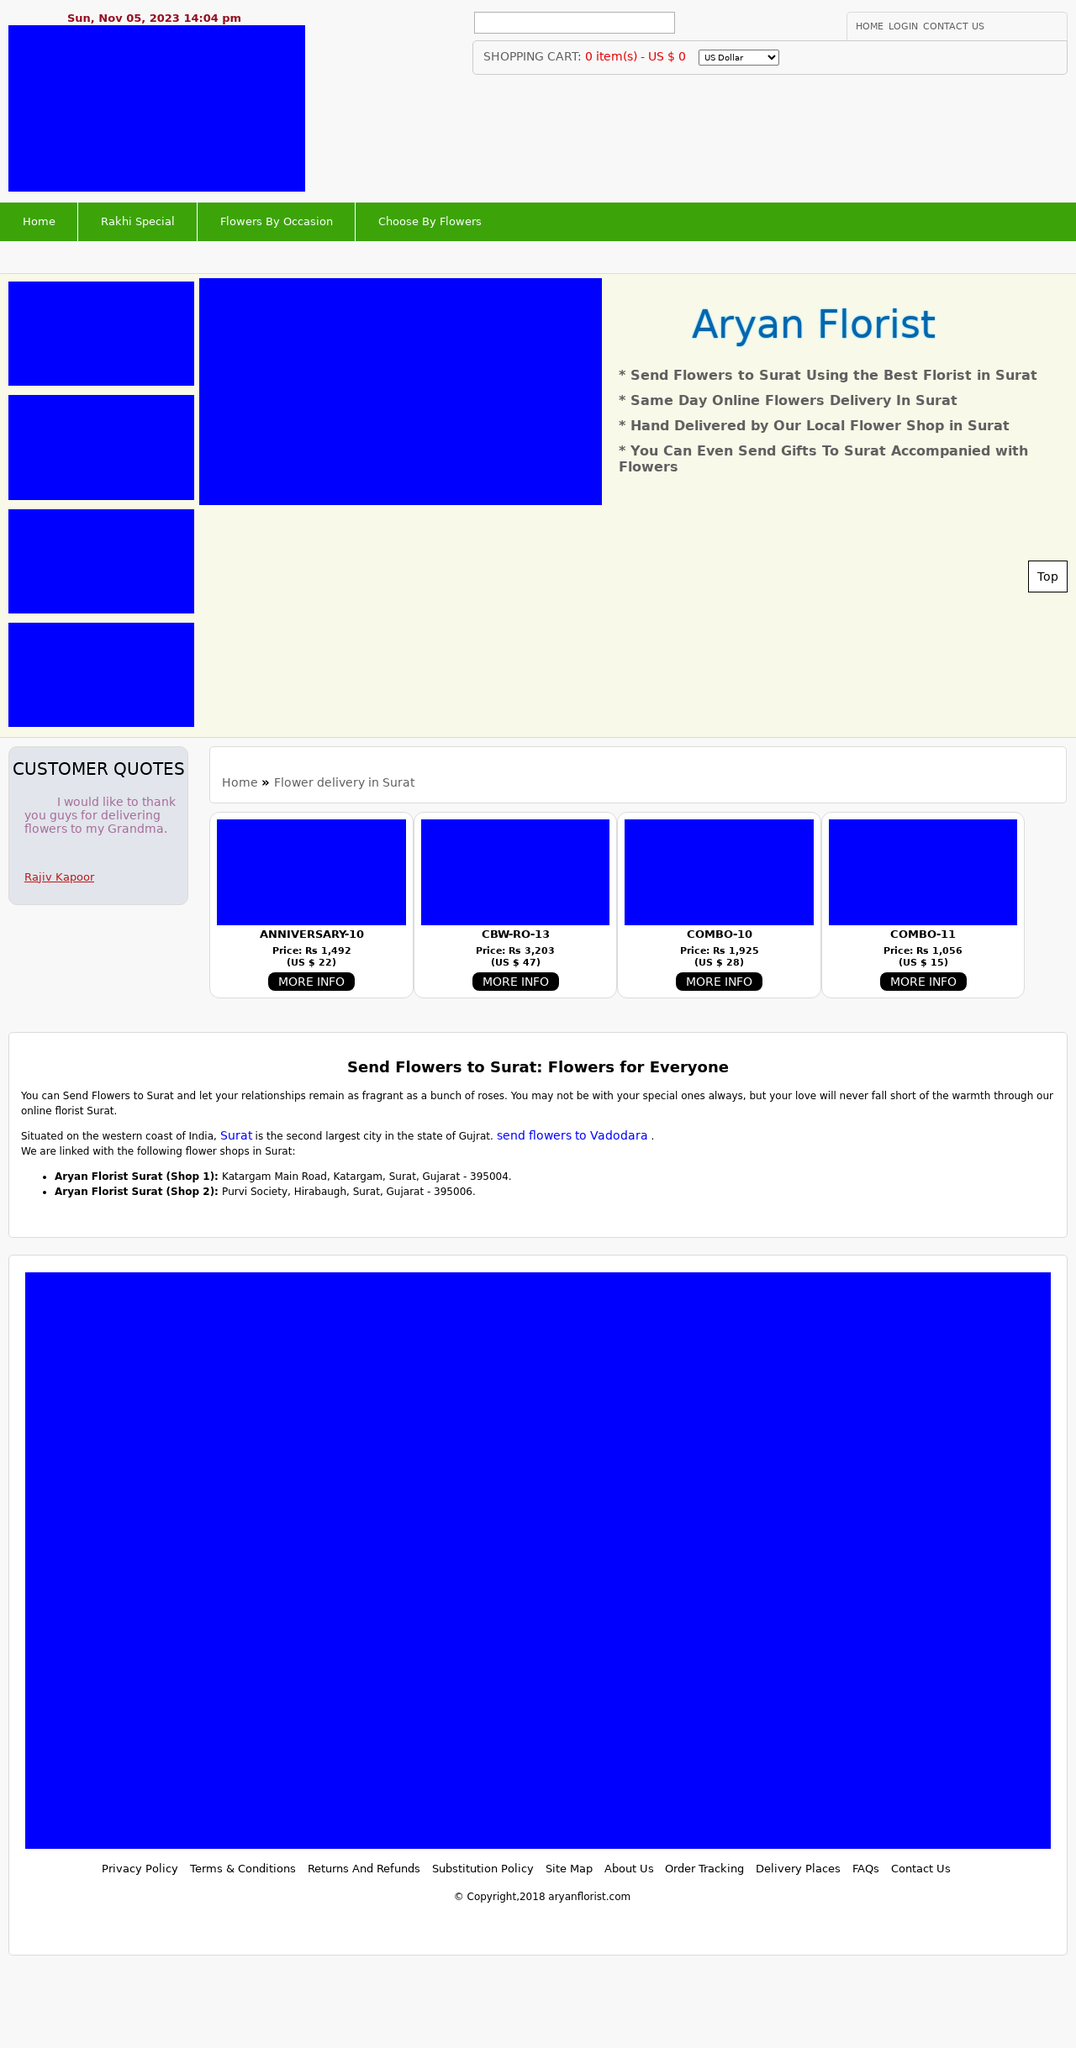How can I start building this website with HTML from the ground up? To start building a website similar to the one displayed in the image, you can begin with a simple HTML structure. Firstly, ensure you have the following tools: a text editor (like Notepad++ or Visual Studio Code) and a web browser to view your progress. Here is a basic structure:
<!DOCTYPE html>
<html lang="en">
<head>
    <meta charset="UTF-8">
    <meta name="viewport" content="width=device-width, initial-scale=1.0">
    <title>Your Website's Title</title>
    <link rel="stylesheet" href="styles.css">
</head>
<body>
    <header>
        <!--Navigation bar goes here-->
    </header>
    <main>
        <!--Main content like images and description-->
    </main>
    <footer>
        <!--Footer content goes here-->
    </footer>
</body>
</html>
Adjust the elements such as header, main, and footer as per your layout needs. Add CSS in a separate file linked in your HTML to style the website according to your visual preferences. 